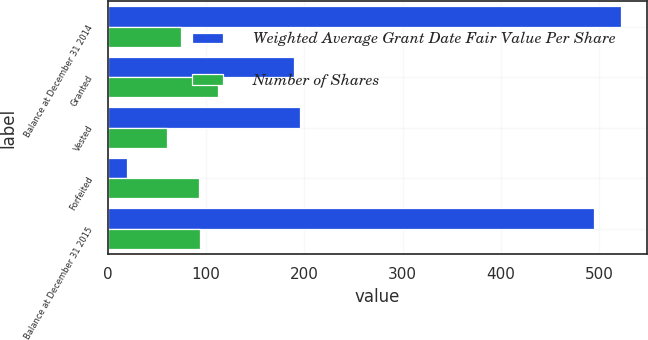<chart> <loc_0><loc_0><loc_500><loc_500><stacked_bar_chart><ecel><fcel>Balance at December 31 2014<fcel>Granted<fcel>Vested<fcel>Forfeited<fcel>Balance at December 31 2015<nl><fcel>Weighted Average Grant Date Fair Value Per Share<fcel>522<fcel>189<fcel>196<fcel>20<fcel>495<nl><fcel>Number of Shares<fcel>74.83<fcel>112.02<fcel>60.5<fcel>93.2<fcel>93.88<nl></chart> 